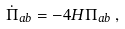<formula> <loc_0><loc_0><loc_500><loc_500>\dot { \Pi } _ { a b } = - 4 H \Pi _ { a b } \, ,</formula> 